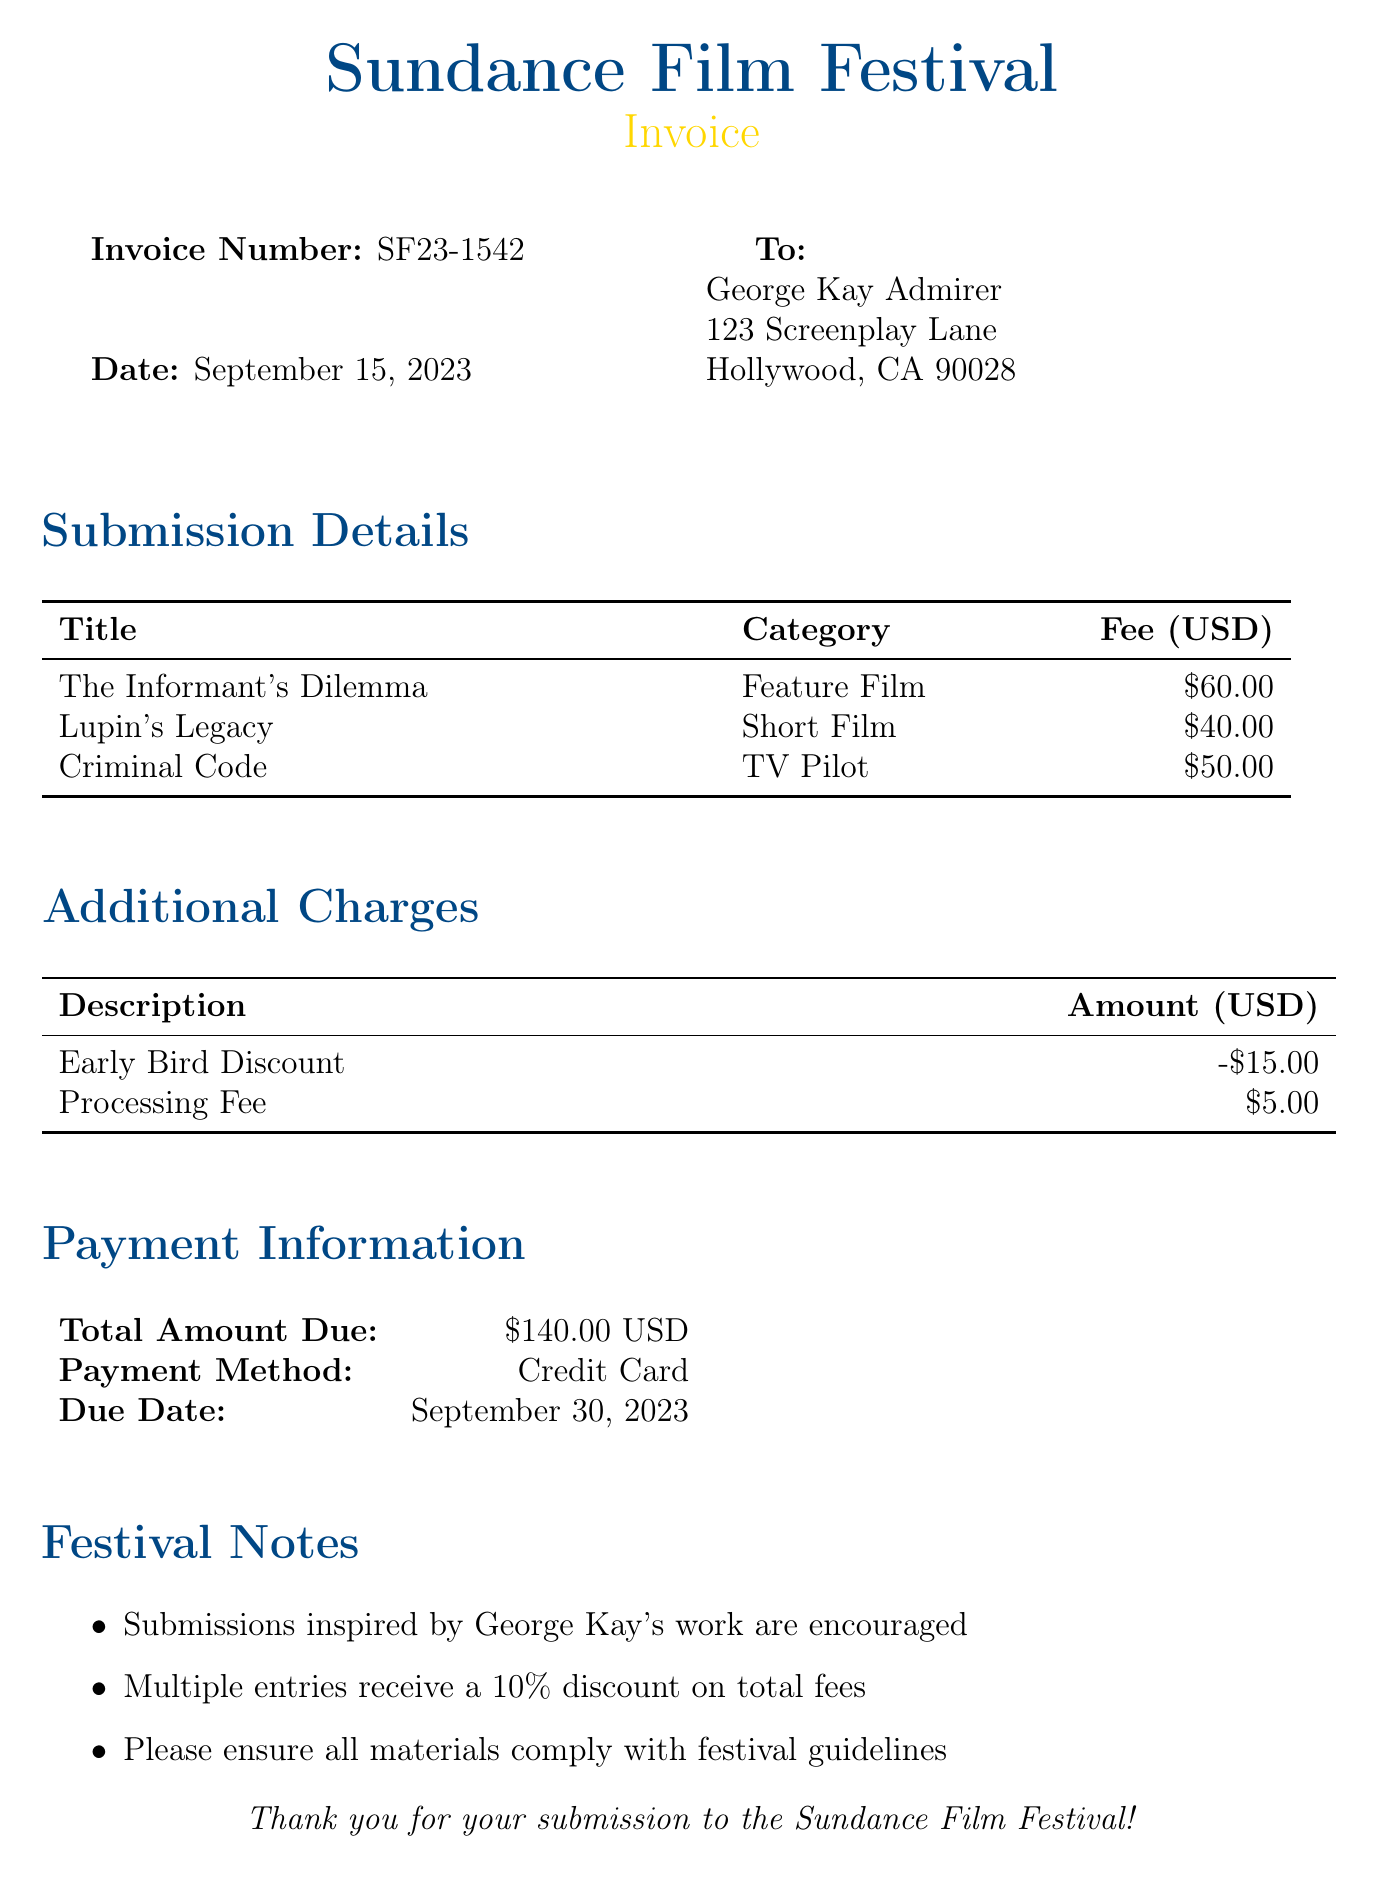What is the invoice number? The invoice number is listed at the top of the document under Invoice Number.
Answer: SF23-1542 What is the total amount due? The total amount due is specified in the Payment Information section of the document.
Answer: $140.00 USD What is the submission date? The submission date is mentioned in the header of the document.
Answer: September 15, 2023 How much is the processing fee? The processing fee is found in the Additional Charges section of the document.
Answer: $5.00 What title is listed under Feature Film? The title categorized as Feature Film is given in the Submission Details section.
Answer: The Informant's Dilemma What discount is applied for early submission? The early bird discount is noted in the Additional Charges section of the document.
Answer: -$15.00 Which payment method is accepted? The accepted payment method is stated in the Payment Information section of the document.
Answer: Credit Card How many entries are listed in the submission details? The number of entries is the count of titles in the Submission Details table.
Answer: 3 When is the payment due? The payment due date is mentioned in the Payment Information section of the document.
Answer: September 30, 2023 